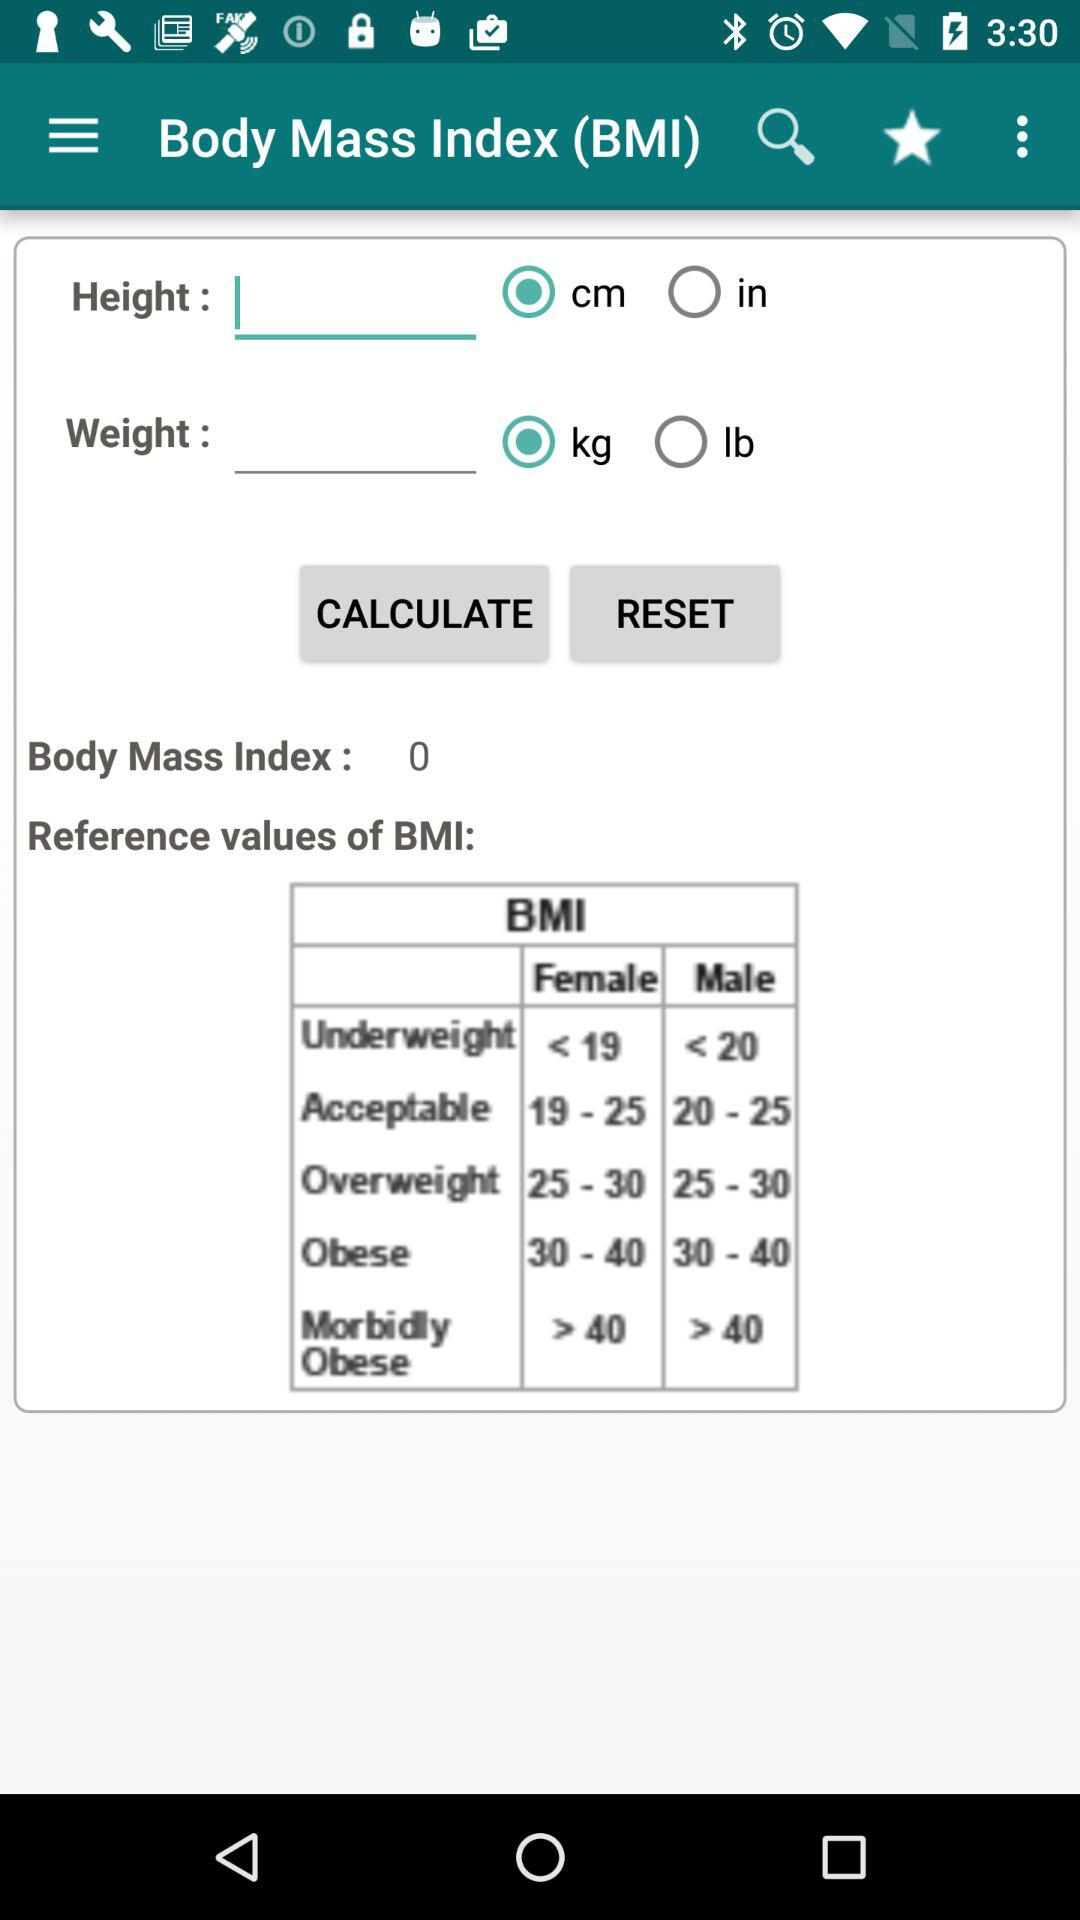What is the value of the body mass index? The value is 0. 